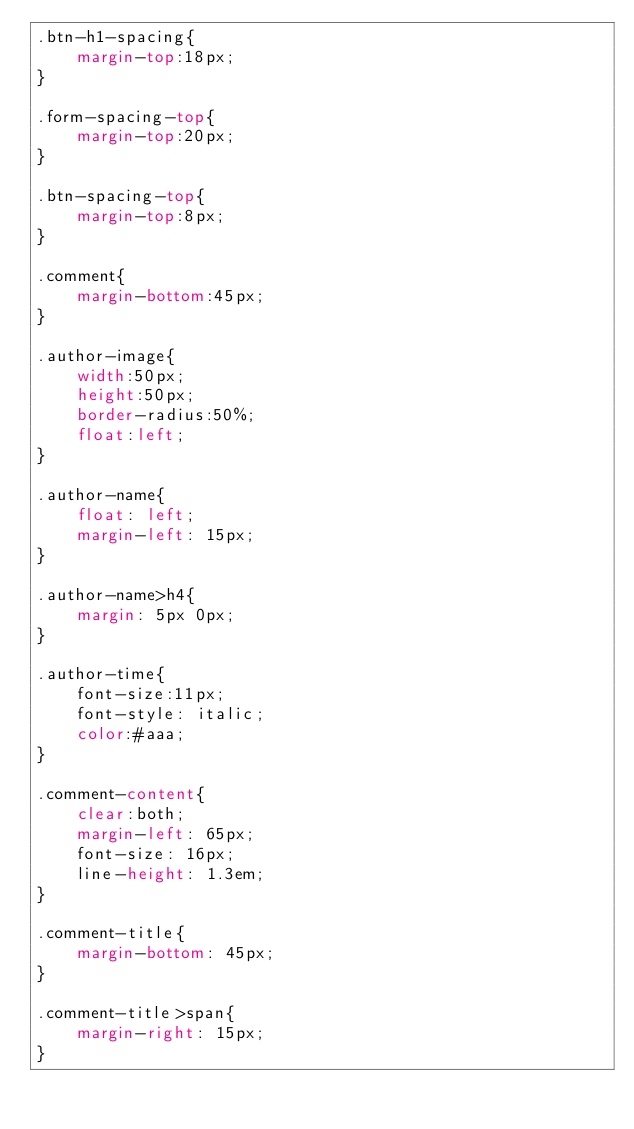<code> <loc_0><loc_0><loc_500><loc_500><_CSS_>.btn-h1-spacing{
	margin-top:18px;
}

.form-spacing-top{
	margin-top:20px;
}

.btn-spacing-top{
	margin-top:8px;
}

.comment{
	margin-bottom:45px;
}

.author-image{
	width:50px;
	height:50px;
	border-radius:50%;
	float:left;
}

.author-name{
	float: left;
	margin-left: 15px;
}

.author-name>h4{
	margin: 5px 0px;
}

.author-time{
	font-size:11px;
	font-style: italic;
	color:#aaa;
}

.comment-content{
	clear:both;
	margin-left: 65px;
	font-size: 16px;
	line-height: 1.3em;
}

.comment-title{
	margin-bottom: 45px;
}

.comment-title>span{
	margin-right: 15px;
}</code> 